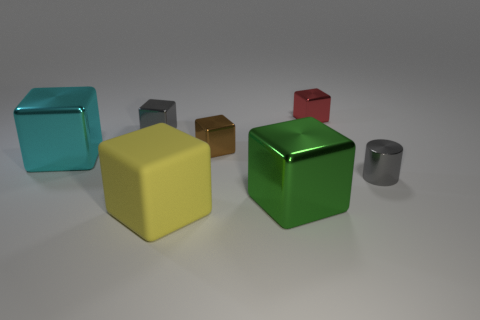Is the size of the metallic object that is right of the red object the same as the gray shiny object that is to the left of the red metallic thing?
Provide a short and direct response. Yes. There is a thing that is behind the cyan block and left of the big yellow block; what is its material?
Your answer should be compact. Metal. There is a cyan metallic block; how many tiny metal things are in front of it?
Provide a succinct answer. 1. Are there any other things that are the same size as the green object?
Make the answer very short. Yes. What color is the tiny cylinder that is the same material as the small brown cube?
Provide a short and direct response. Gray. Do the tiny red object and the yellow rubber thing have the same shape?
Provide a succinct answer. Yes. How many large objects are in front of the tiny gray shiny cylinder and to the left of the large green thing?
Offer a terse response. 1. What number of shiny objects are brown things or big blue things?
Offer a terse response. 1. There is a gray shiny thing that is behind the big cyan shiny thing to the left of the brown object; how big is it?
Give a very brief answer. Small. There is a small block that is the same color as the tiny metallic cylinder; what is its material?
Provide a short and direct response. Metal. 